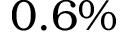Convert formula to latex. <formula><loc_0><loc_0><loc_500><loc_500>0 . 6 \%</formula> 